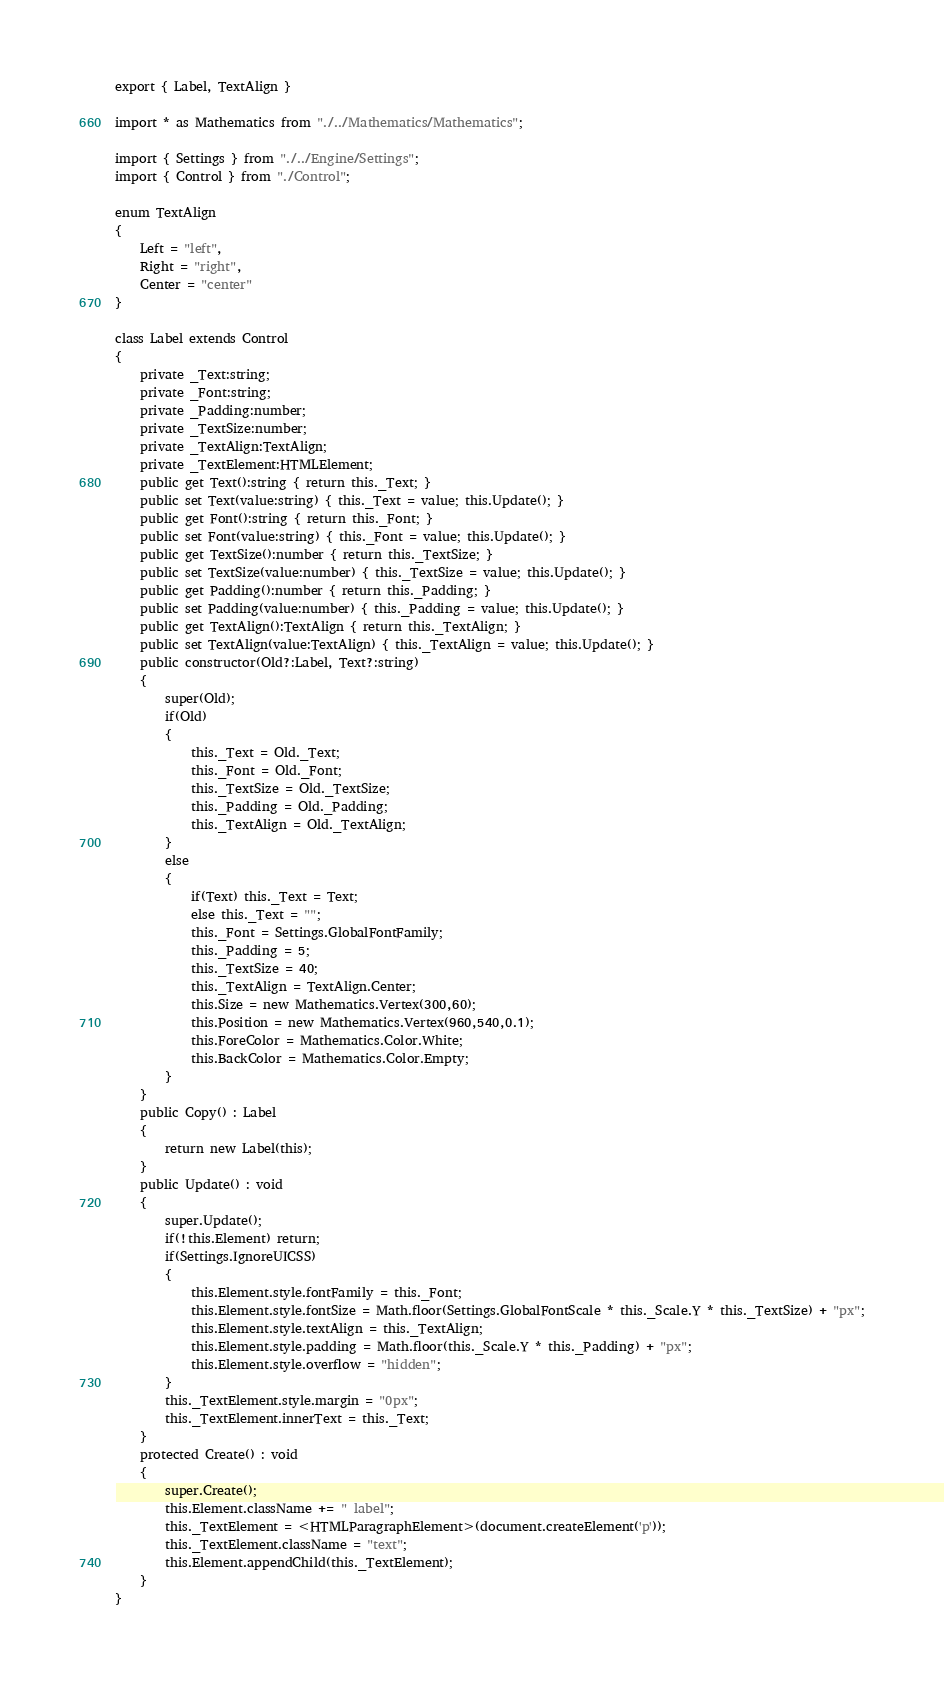Convert code to text. <code><loc_0><loc_0><loc_500><loc_500><_TypeScript_>export { Label, TextAlign }

import * as Mathematics from "./../Mathematics/Mathematics";

import { Settings } from "./../Engine/Settings";
import { Control } from "./Control";

enum TextAlign
{
    Left = "left",
    Right = "right",
    Center = "center"
}

class Label extends Control
{
    private _Text:string;
    private _Font:string;
    private _Padding:number;
    private _TextSize:number;
    private _TextAlign:TextAlign;
    private _TextElement:HTMLElement;
    public get Text():string { return this._Text; }
    public set Text(value:string) { this._Text = value; this.Update(); }
    public get Font():string { return this._Font; }
    public set Font(value:string) { this._Font = value; this.Update(); }
    public get TextSize():number { return this._TextSize; }
    public set TextSize(value:number) { this._TextSize = value; this.Update(); }
    public get Padding():number { return this._Padding; }
    public set Padding(value:number) { this._Padding = value; this.Update(); }
    public get TextAlign():TextAlign { return this._TextAlign; }
    public set TextAlign(value:TextAlign) { this._TextAlign = value; this.Update(); }
    public constructor(Old?:Label, Text?:string)
    {
        super(Old);
        if(Old)
        {
            this._Text = Old._Text;
            this._Font = Old._Font;
            this._TextSize = Old._TextSize;
            this._Padding = Old._Padding;
            this._TextAlign = Old._TextAlign;
        }
        else
        {
            if(Text) this._Text = Text;
            else this._Text = "";
            this._Font = Settings.GlobalFontFamily;
            this._Padding = 5;
            this._TextSize = 40;
            this._TextAlign = TextAlign.Center;
            this.Size = new Mathematics.Vertex(300,60);
            this.Position = new Mathematics.Vertex(960,540,0.1);
            this.ForeColor = Mathematics.Color.White;
            this.BackColor = Mathematics.Color.Empty;
        }
    }
    public Copy() : Label
    {
        return new Label(this);
    }
    public Update() : void
    {
        super.Update();
        if(!this.Element) return;
        if(Settings.IgnoreUICSS)
        {
            this.Element.style.fontFamily = this._Font;
            this.Element.style.fontSize = Math.floor(Settings.GlobalFontScale * this._Scale.Y * this._TextSize) + "px";
            this.Element.style.textAlign = this._TextAlign;
            this.Element.style.padding = Math.floor(this._Scale.Y * this._Padding) + "px";
            this.Element.style.overflow = "hidden";
        }
        this._TextElement.style.margin = "0px";
        this._TextElement.innerText = this._Text;
    }
    protected Create() : void
    {
        super.Create();
        this.Element.className += " label";
        this._TextElement = <HTMLParagraphElement>(document.createElement('p'));
        this._TextElement.className = "text";
        this.Element.appendChild(this._TextElement);
    }
}</code> 